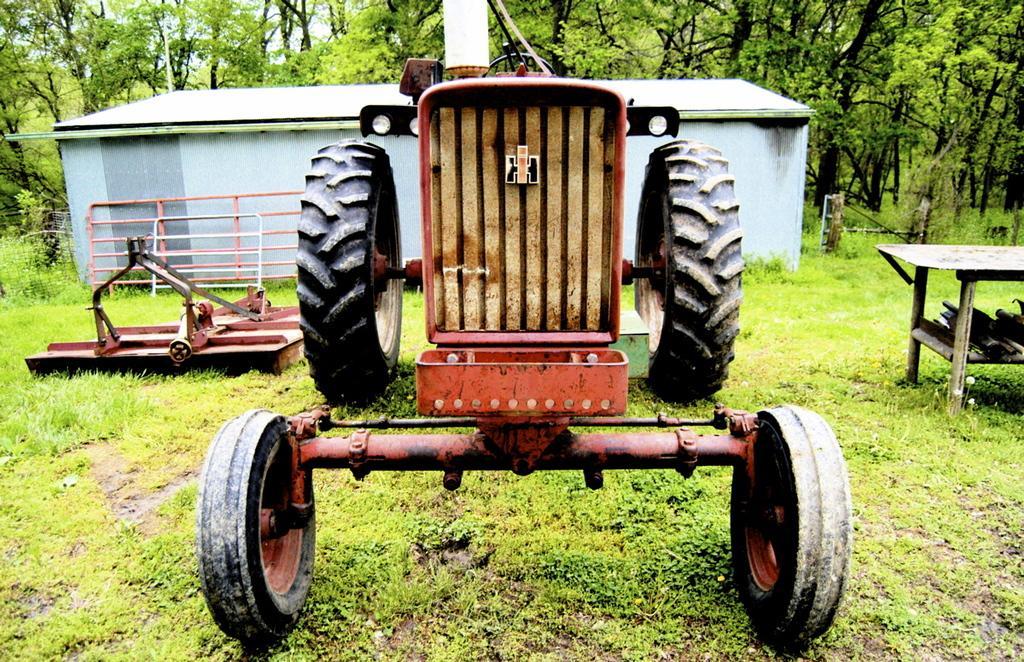Could you give a brief overview of what you see in this image? In this image I can see a vehicle. At the right there is a table. In the background there is shed and there are some trees. 